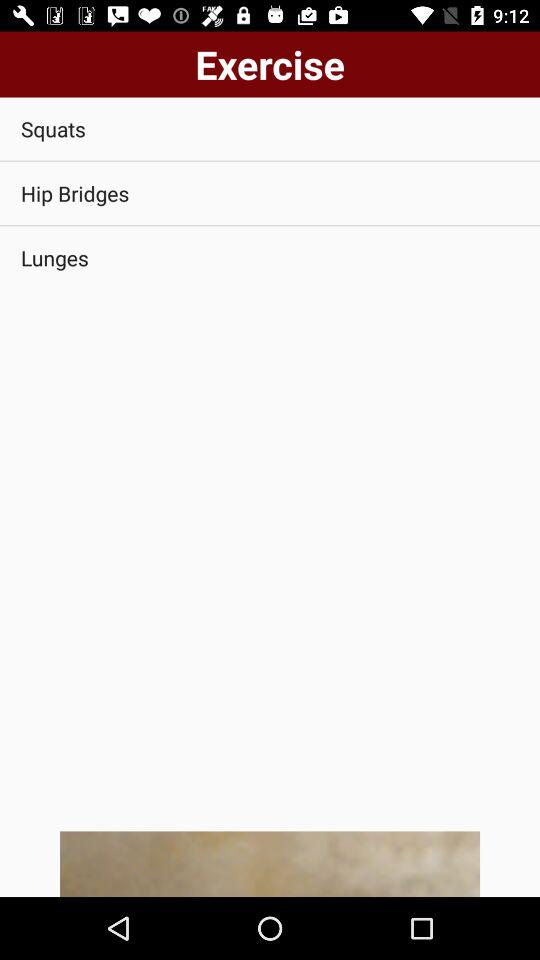How many lunges have been completed?
When the provided information is insufficient, respond with <no answer>. <no answer> 